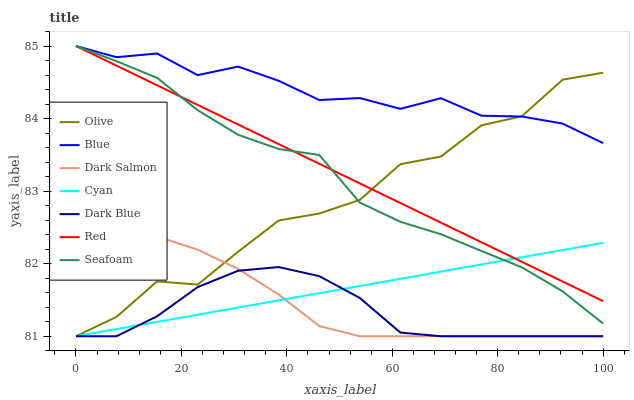Does Dark Blue have the minimum area under the curve?
Answer yes or no. Yes. Does Blue have the maximum area under the curve?
Answer yes or no. Yes. Does Dark Salmon have the minimum area under the curve?
Answer yes or no. No. Does Dark Salmon have the maximum area under the curve?
Answer yes or no. No. Is Red the smoothest?
Answer yes or no. Yes. Is Olive the roughest?
Answer yes or no. Yes. Is Dark Salmon the smoothest?
Answer yes or no. No. Is Dark Salmon the roughest?
Answer yes or no. No. Does Dark Salmon have the lowest value?
Answer yes or no. Yes. Does Seafoam have the lowest value?
Answer yes or no. No. Does Red have the highest value?
Answer yes or no. Yes. Does Dark Salmon have the highest value?
Answer yes or no. No. Is Dark Salmon less than Seafoam?
Answer yes or no. Yes. Is Red greater than Dark Blue?
Answer yes or no. Yes. Does Cyan intersect Olive?
Answer yes or no. Yes. Is Cyan less than Olive?
Answer yes or no. No. Is Cyan greater than Olive?
Answer yes or no. No. Does Dark Salmon intersect Seafoam?
Answer yes or no. No. 